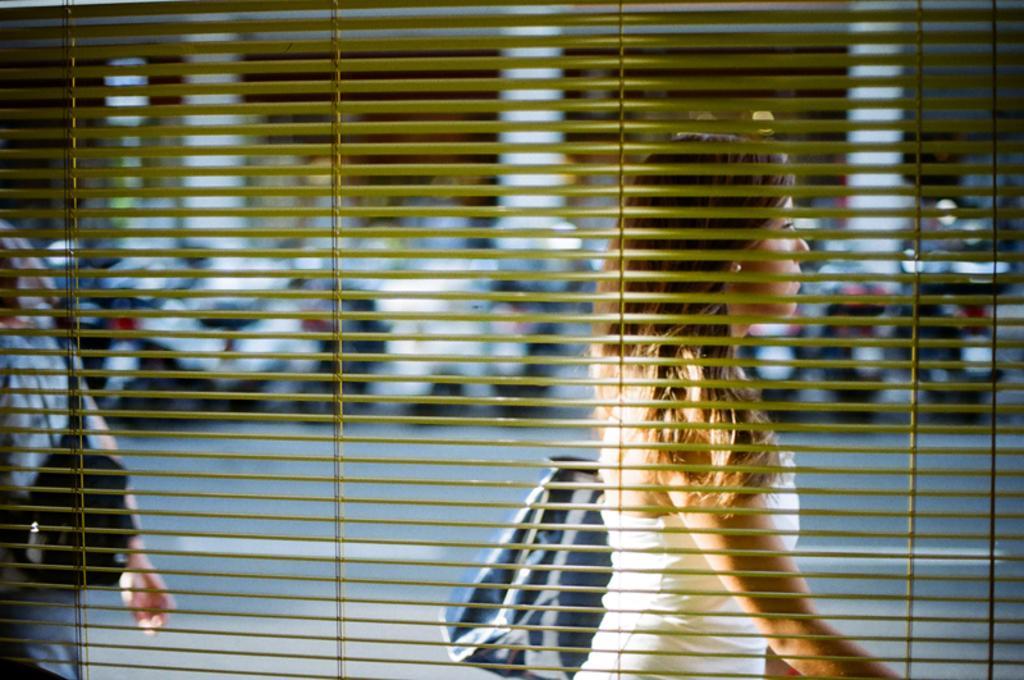Describe this image in one or two sentences. In this picture from the blinds I can see couple of them walking, they are wearing bags and I can see motorcycles in the background. 